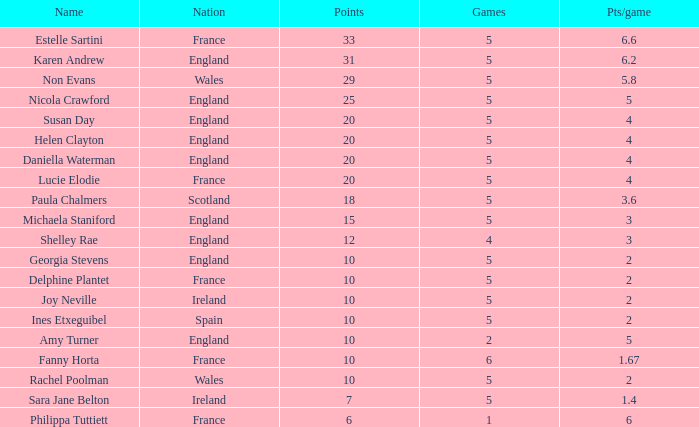Can you tell me the lowest Pts/game that has the Games larger than 6? None. 